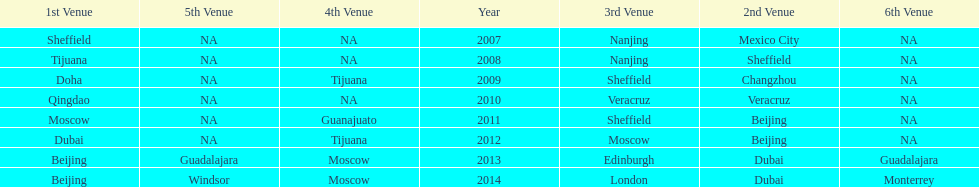How long, in years, has the this world series been occurring? 7 years. 